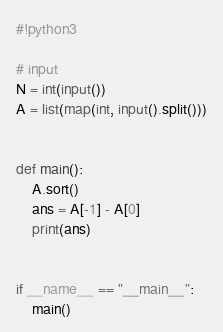Convert code to text. <code><loc_0><loc_0><loc_500><loc_500><_Python_>#!python3

# input
N = int(input())
A = list(map(int, input().split()))


def main():
    A.sort()
    ans = A[-1] - A[0]
    print(ans)


if __name__ == "__main__":
    main()
</code> 